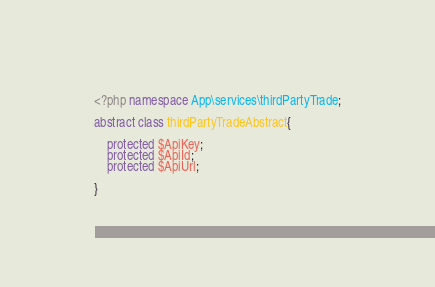Convert code to text. <code><loc_0><loc_0><loc_500><loc_500><_PHP_><?php namespace App\services\thirdPartyTrade;

abstract class thirdPartyTradeAbstract{

    protected $ApiKey;
    protected $ApiId;
    protected $ApiUrl;

}</code> 